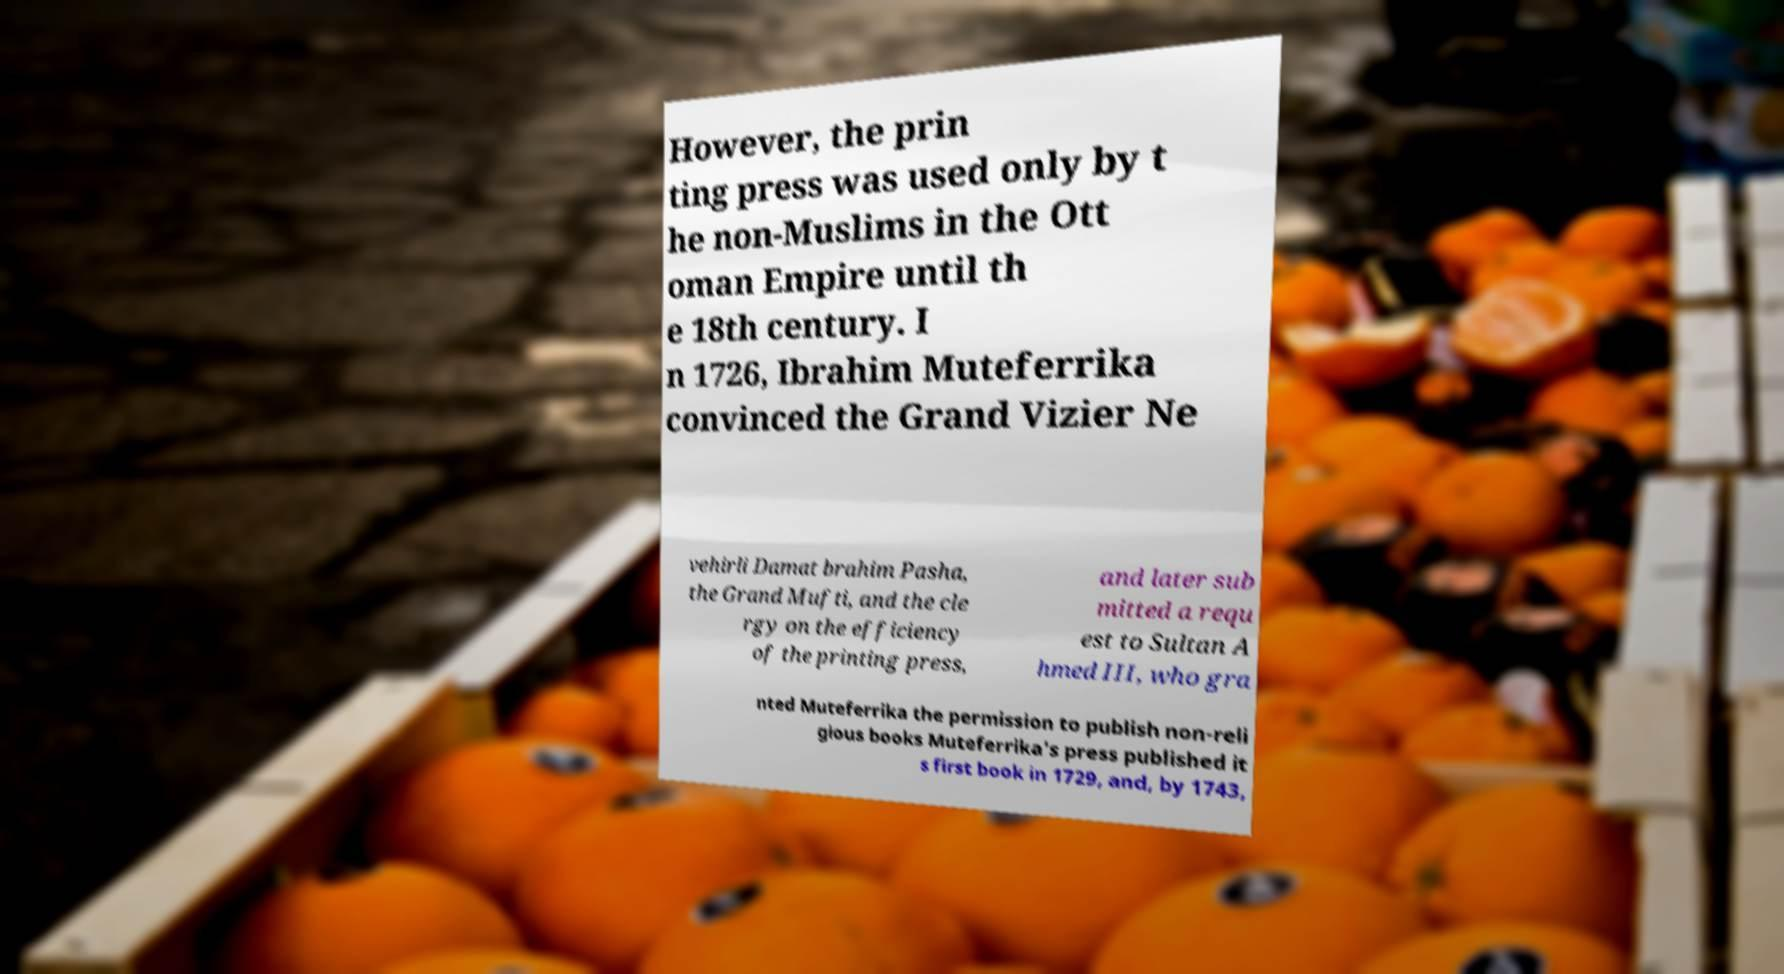I need the written content from this picture converted into text. Can you do that? However, the prin ting press was used only by t he non-Muslims in the Ott oman Empire until th e 18th century. I n 1726, Ibrahim Muteferrika convinced the Grand Vizier Ne vehirli Damat brahim Pasha, the Grand Mufti, and the cle rgy on the efficiency of the printing press, and later sub mitted a requ est to Sultan A hmed III, who gra nted Muteferrika the permission to publish non-reli gious books Muteferrika's press published it s first book in 1729, and, by 1743, 